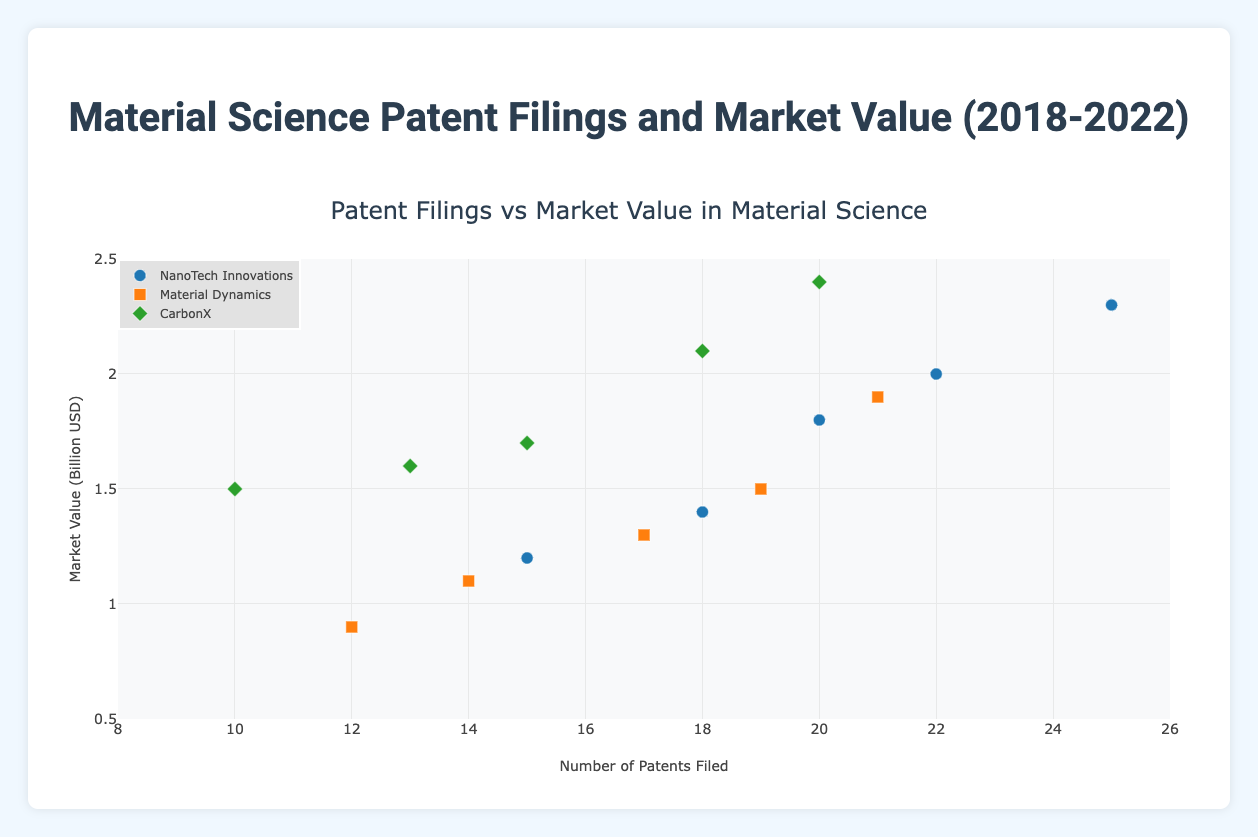What's the title of the figure? The title is located at the top center of the figure and reads "Material Science Patent Filings and Market Value (2018-2022)".
Answer: Material Science Patent Filings and Market Value (2018-2022) Which company filed the most patents in 2022? Looking at the data points for 2022 and comparing the x-axis values, NanoTech Innovations has the rightmost point indicating 25 patents filed.
Answer: NanoTech Innovations What is the y-axis representing in this scatter plot? The y-axis is labeled "Market Value (Billion USD)", representing the market value of companies in billion USD.
Answer: Market Value (Billion USD) How many unique companies are represented in the plot? By examining the legend, there are three unique companies: NanoTech Innovations, Material Dynamics, and CarbonX.
Answer: 3 Which company had the highest market value in 2021? Comparing the y-axis values for 2021, CarbonX has the highest point at 2.1 billion USD.
Answer: CarbonX What is the trend of market value for NanoTech Innovations from 2018 to 2022? Observing the y-axis values for NanoTech Innovations over the years 2018-2022, the market value is gradually increasing from 1.2 to 2.3 billion USD.
Answer: Increasing How does the number of patents filed by CarbonX in 2020 compare to that in 2021? Comparing the x-axis values for CarbonX in 2020 (15 patents) and 2021 (18 patents), there is an increase by 3 patents.
Answer: Increase by 3 Which year had the highest average market value across all companies? Calculating the average market values for each year: 2018 (1.2+0.9+1.5)/3 = 1.2, 2019 (1.4+1.1+1.6)/3 ≈ 1.37, 2020 (1.8+1.3+1.7)/3 ≈ 1.60, 2021 (2.0+1.5+2.1)/3 ≈ 1.87, 2022 (2.3+1.9+2.4)/3 = 2.2. The highest average is in 2022.
Answer: 2022 What is the relationship between patents filed and market value for Material Dynamics in 2019? For Material Dynamics in 2019, looking at the point, 14 patents are filed and the market value is 1.1 billion USD. There appears to be a positive correlation when compared to other years.
Answer: Positive correlation Which company showed the most consistent increase in both patents filed and market value from 2018 to 2022? By examining the trends for all companies, NanoTech Innovations shows a consistent upward trend in both patents filed (15 to 25) and market value (1.2 to 2.3 billion USD).
Answer: NanoTech Innovations 